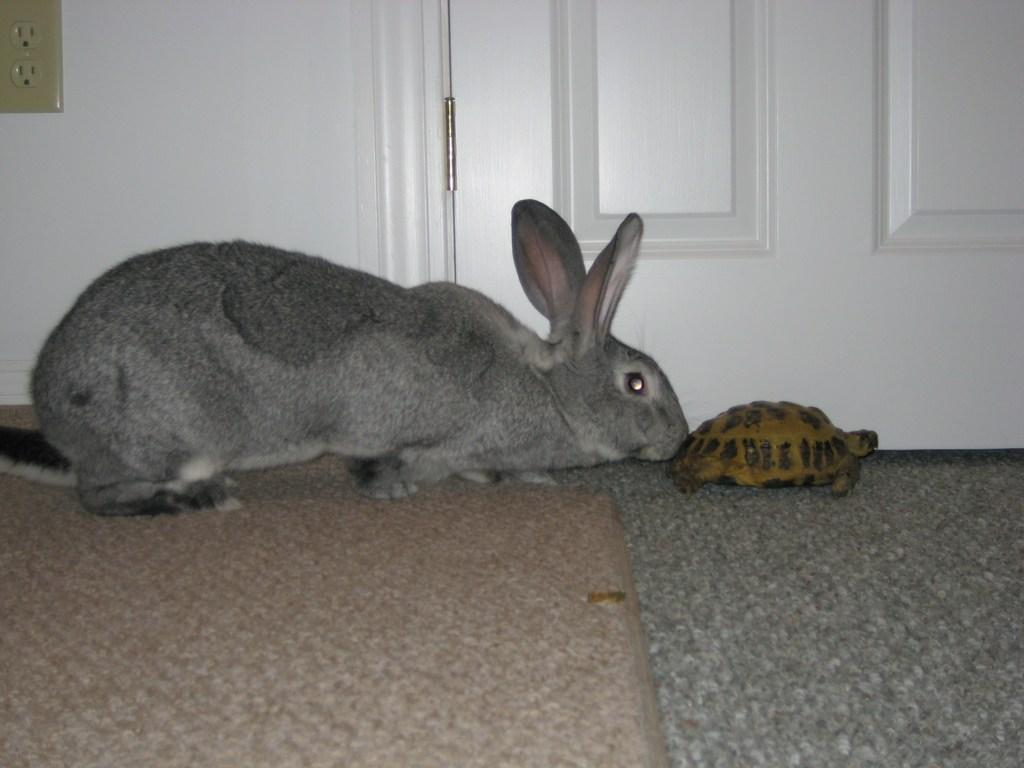What animal can be seen laying on the floor in the image? There is a rabbit laying on the floor in the image. What other animal is present in the image? There is a small tortoise in front of the rabbit. What can be seen in the background of the image? There is a door visible in the background of the image. Where is the switch board located in the image? The switch board is on the left side top of the image. How many cars are parked outside the door in the image? There are no cars visible in the image; only a rabbit, a tortoise, a door, and a switch board are present. 